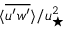<formula> <loc_0><loc_0><loc_500><loc_500>\langle \overline { { u ^ { \prime } w ^ { \prime } } } \rangle / u _ { ^ { * } } ^ { 2 }</formula> 